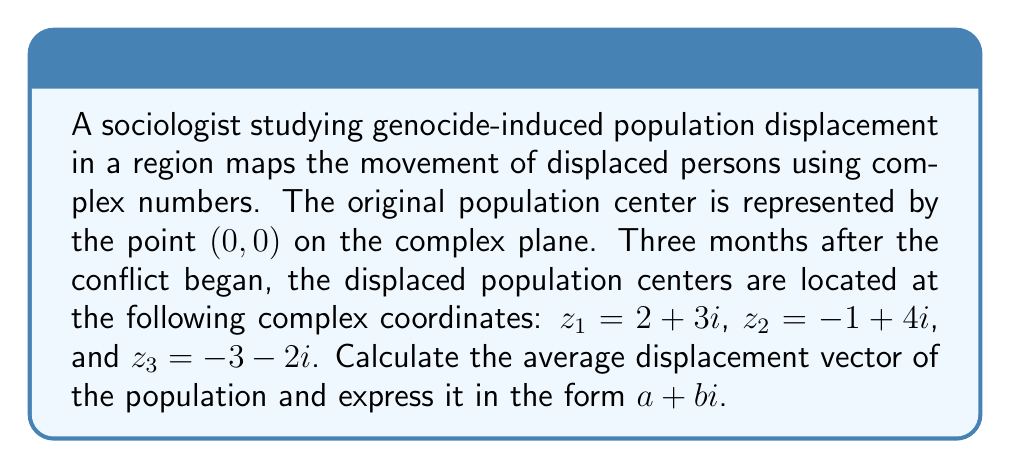Teach me how to tackle this problem. To solve this problem, we'll follow these steps:

1) The average displacement vector is the arithmetic mean of the three given complex numbers.

2) To calculate the arithmetic mean, we add the complex numbers and divide by the number of points:

   $$\text{Average} = \frac{z_1 + z_2 + z_3}{3}$$

3) Let's substitute the given values:

   $$\text{Average} = \frac{(2+3i) + (-1+4i) + (-3-2i)}{3}$$

4) Now, we'll add the complex numbers. Remember to add real and imaginary parts separately:

   $$\text{Average} = \frac{(2-1-3) + (3i+4i-2i)}{3}$$

5) Simplify:

   $$\text{Average} = \frac{-2 + 5i}{3}$$

6) To express this in $a+bi$ form, we need to divide both the real and imaginary parts by 3:

   $$\text{Average} = \frac{-2}{3} + \frac{5}{3}i$$

This result represents the average displacement vector of the population on the complex plane.
Answer: $-\frac{2}{3} + \frac{5}{3}i$ 